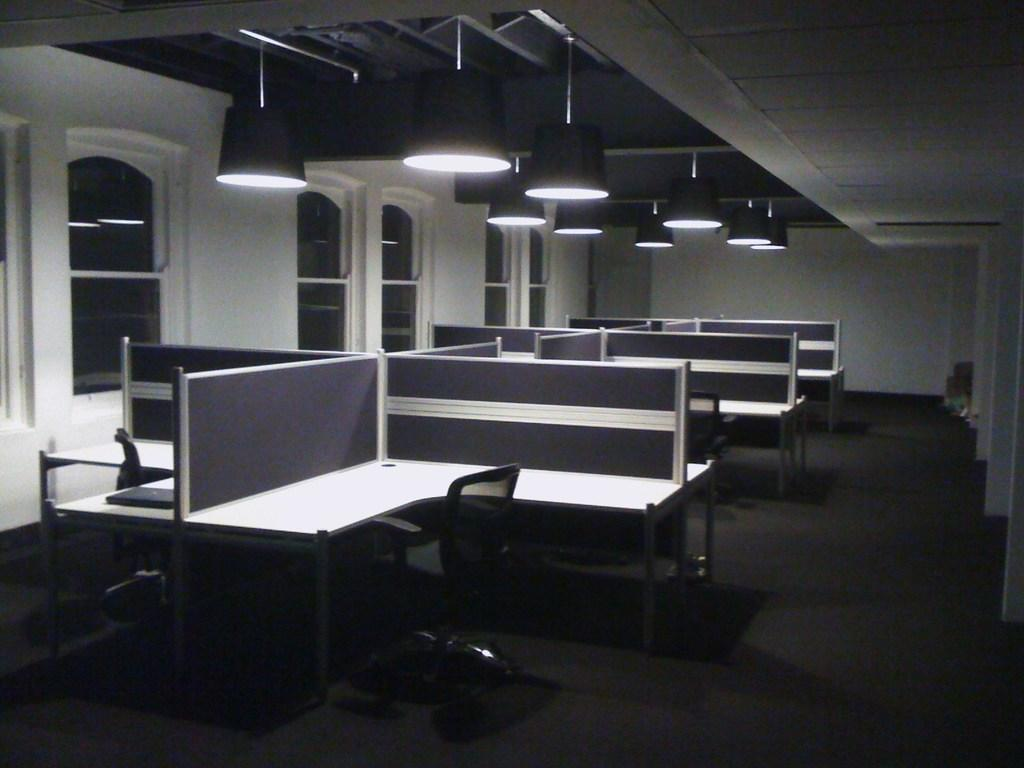What type of furniture is present in the image? There are desks and chairs in the image. Can you describe the object on one of the desks? Unfortunately, the facts provided do not give any information about the object on the desk. What is located at the top of the image? There are lights at the top of the image. What can be seen in the background of the image? There are windows visible in the background of the image. Where are the windows located? The windows are on a wall. Can you hear the loaf crying in the image? There is no loaf present in the image, and therefore no crying can be heard. 